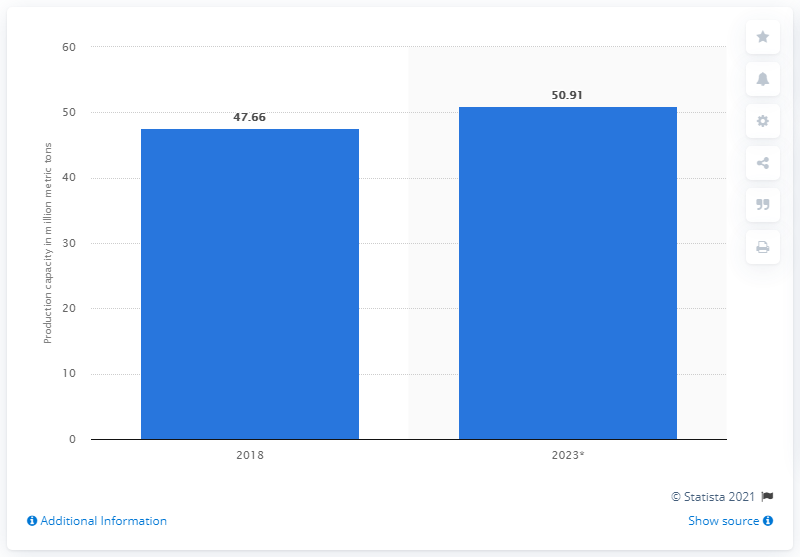Specify some key components in this picture. In 2018, the global production capacity of ethylene dichloride was 47.66 million metric tons. In 2018, the United States produced 50.91 metric tons of EDC. The global production capacity of ethylene dichloride is projected to increase by 2023, with an estimated increase of 50.91%. 